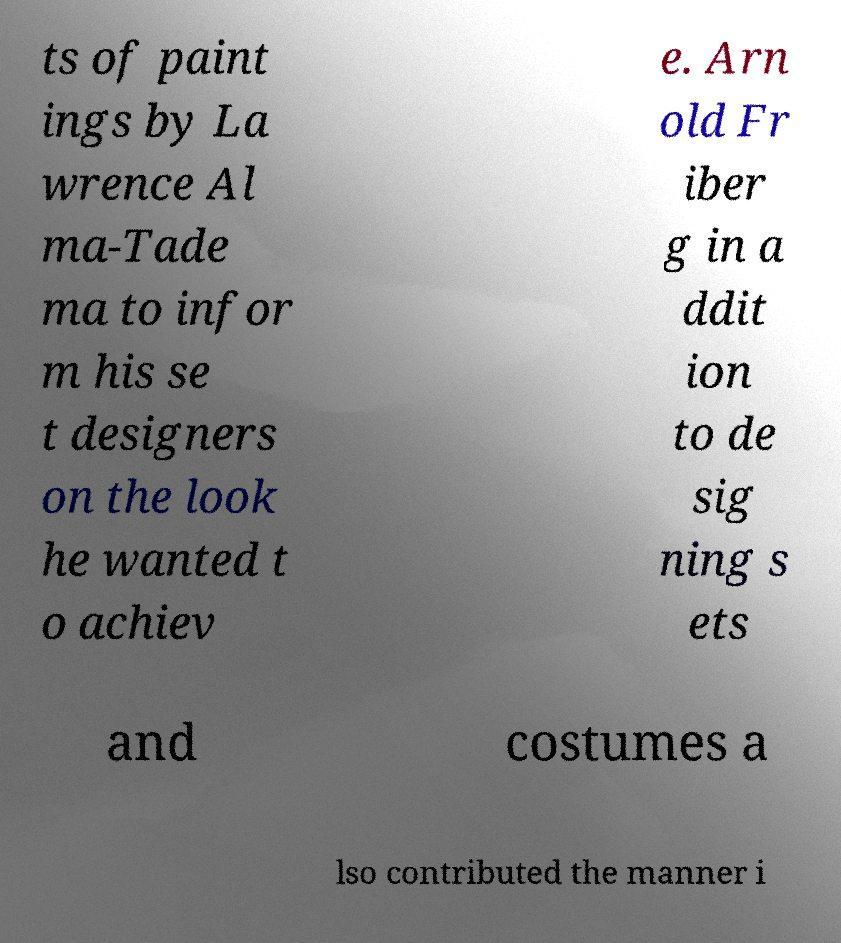There's text embedded in this image that I need extracted. Can you transcribe it verbatim? ts of paint ings by La wrence Al ma-Tade ma to infor m his se t designers on the look he wanted t o achiev e. Arn old Fr iber g in a ddit ion to de sig ning s ets and costumes a lso contributed the manner i 